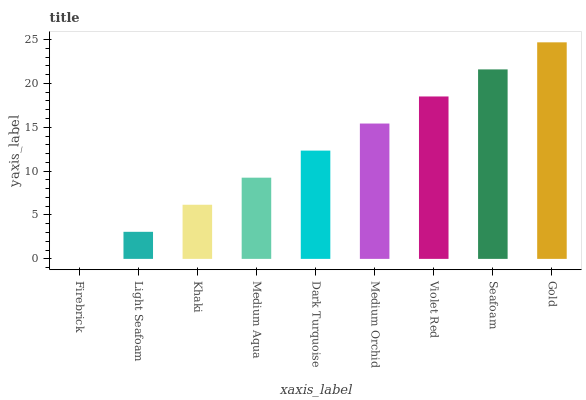Is Firebrick the minimum?
Answer yes or no. Yes. Is Gold the maximum?
Answer yes or no. Yes. Is Light Seafoam the minimum?
Answer yes or no. No. Is Light Seafoam the maximum?
Answer yes or no. No. Is Light Seafoam greater than Firebrick?
Answer yes or no. Yes. Is Firebrick less than Light Seafoam?
Answer yes or no. Yes. Is Firebrick greater than Light Seafoam?
Answer yes or no. No. Is Light Seafoam less than Firebrick?
Answer yes or no. No. Is Dark Turquoise the high median?
Answer yes or no. Yes. Is Dark Turquoise the low median?
Answer yes or no. Yes. Is Gold the high median?
Answer yes or no. No. Is Firebrick the low median?
Answer yes or no. No. 